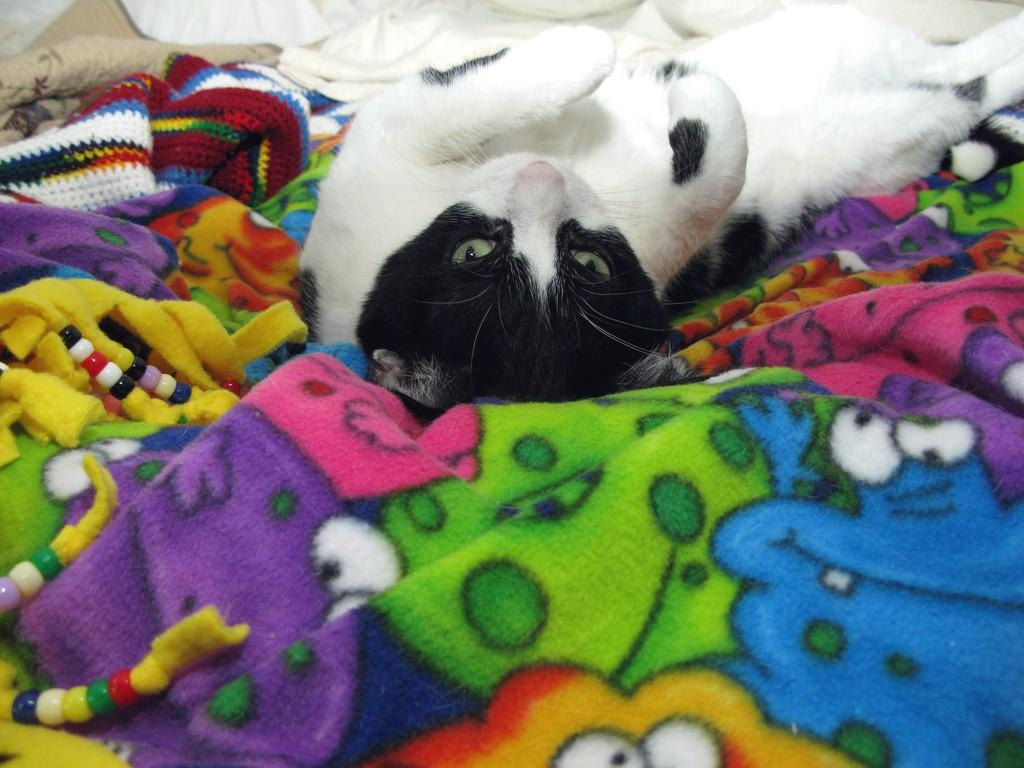What type of animal is in the image? There is a cat in the image. Can you describe the appearance of the cat? The cat is white and black in color. Where is the cat located in the image? The cat is laying on a bed sheet. What colors can be seen on the bed sheet? The bed sheet has green, pink, purple, white, yellow, and orange colors. What type of servant is attending to the cat in the image? There is no servant present in the image; it only features a cat laying on a bed sheet. How does the cat express its feelings of hate in the image? The image does not show any emotions or actions related to hate; it simply depicts a cat laying on a bed sheet. 